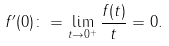<formula> <loc_0><loc_0><loc_500><loc_500>f ^ { \prime } ( 0 ) \colon = \lim _ { t \to 0 ^ { + } } \frac { f ( t ) } { t } = 0 .</formula> 